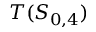Convert formula to latex. <formula><loc_0><loc_0><loc_500><loc_500>T ( S _ { 0 , 4 } )</formula> 